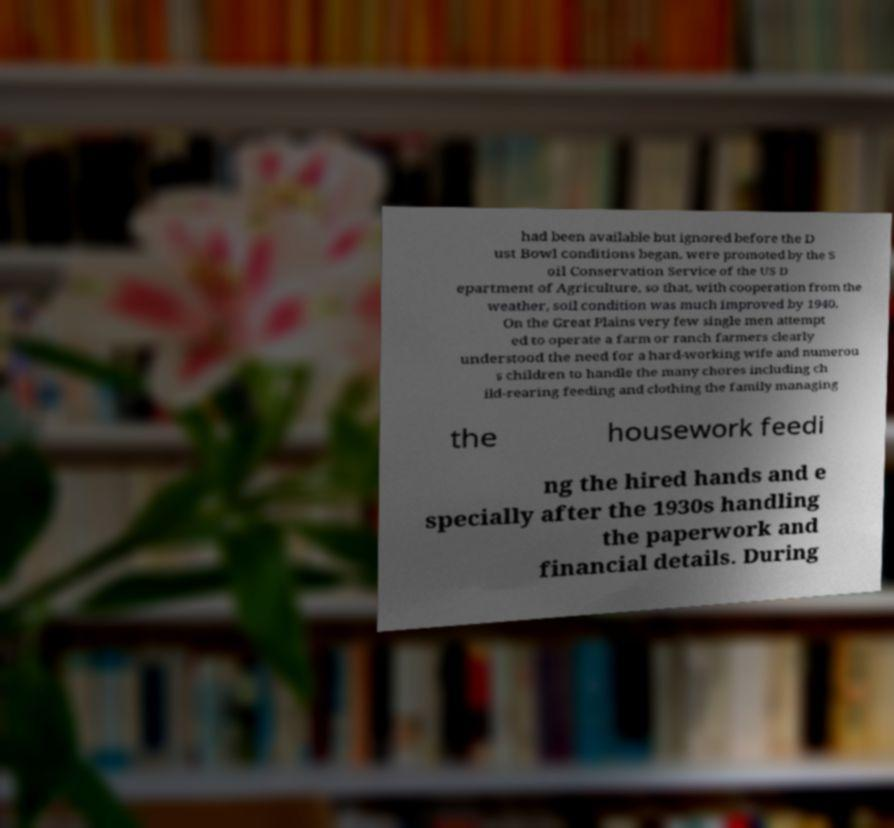Can you read and provide the text displayed in the image?This photo seems to have some interesting text. Can you extract and type it out for me? had been available but ignored before the D ust Bowl conditions began, were promoted by the S oil Conservation Service of the US D epartment of Agriculture, so that, with cooperation from the weather, soil condition was much improved by 1940. On the Great Plains very few single men attempt ed to operate a farm or ranch farmers clearly understood the need for a hard-working wife and numerou s children to handle the many chores including ch ild-rearing feeding and clothing the family managing the housework feedi ng the hired hands and e specially after the 1930s handling the paperwork and financial details. During 